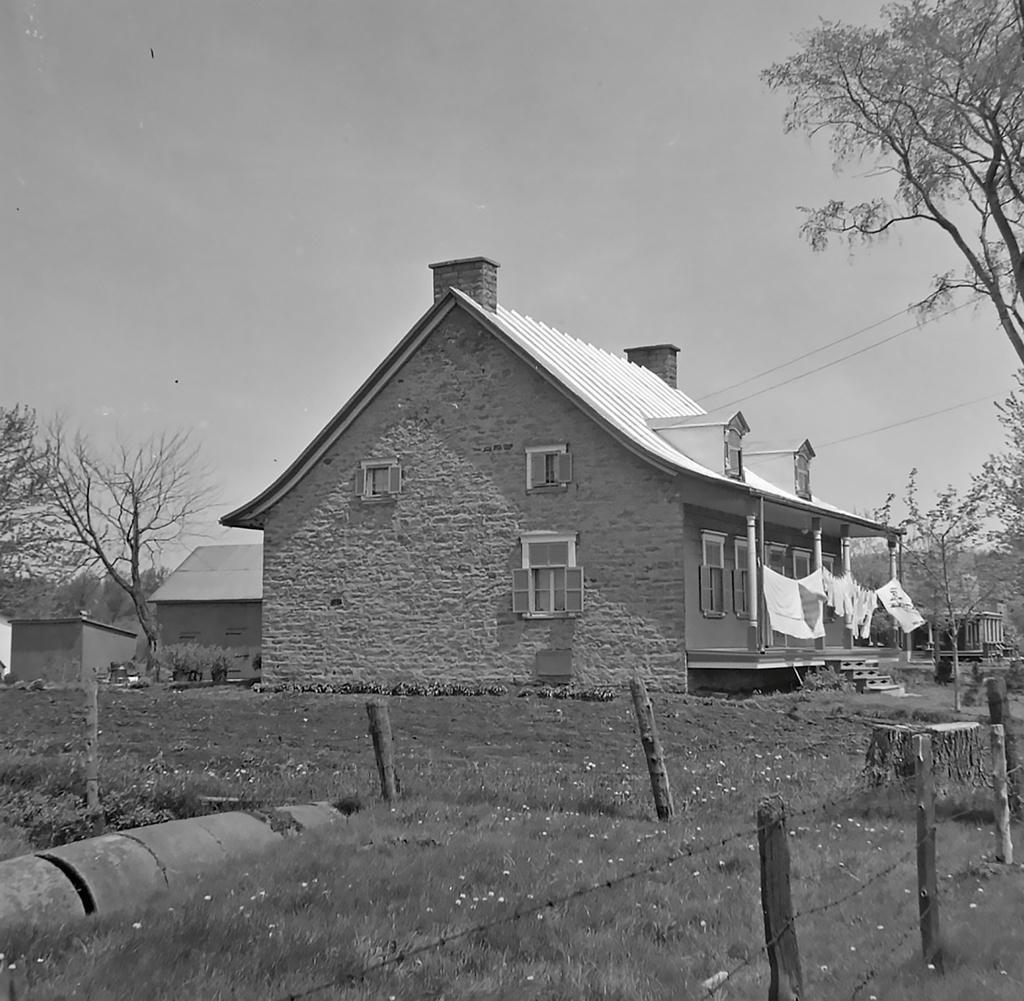How would you summarize this image in a sentence or two? This is a black and white picture, in this image we can see a few houses, there are some trees, plants, flowers, clothes, fence, poles, windows and wires, in the background we can see the sky. 